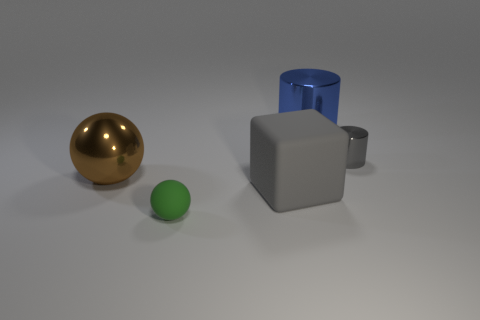Subtract all cylinders. How many objects are left? 3 Add 4 gray matte objects. How many gray matte objects exist? 5 Add 1 small purple matte cylinders. How many objects exist? 6 Subtract 0 purple balls. How many objects are left? 5 Subtract 1 balls. How many balls are left? 1 Subtract all blue cylinders. Subtract all purple balls. How many cylinders are left? 1 Subtract all cyan cylinders. How many yellow blocks are left? 0 Subtract all small cylinders. Subtract all matte cylinders. How many objects are left? 4 Add 1 large gray cubes. How many large gray cubes are left? 2 